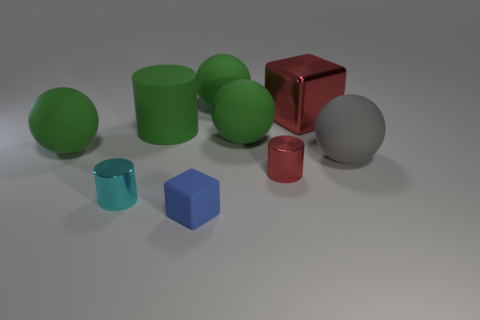Is there any other thing that has the same color as the tiny rubber block?
Offer a very short reply. No. Is the number of small blue rubber objects behind the tiny cyan shiny object greater than the number of small purple spheres?
Provide a short and direct response. No. Is the blue thing the same size as the metallic cube?
Ensure brevity in your answer.  No. What is the material of the other small thing that is the same shape as the tiny cyan object?
Your response must be concise. Metal. How many purple things are tiny matte objects or metal cylinders?
Ensure brevity in your answer.  0. There is a red object behind the small red metal cylinder; what material is it?
Make the answer very short. Metal. Is the number of big gray matte balls greater than the number of red rubber cylinders?
Ensure brevity in your answer.  Yes. Is the shape of the red object left of the red metallic block the same as  the cyan object?
Your answer should be compact. Yes. What number of shiny objects are both right of the tiny blue matte block and in front of the gray matte sphere?
Give a very brief answer. 1. What number of other large shiny things are the same shape as the blue thing?
Your response must be concise. 1. 